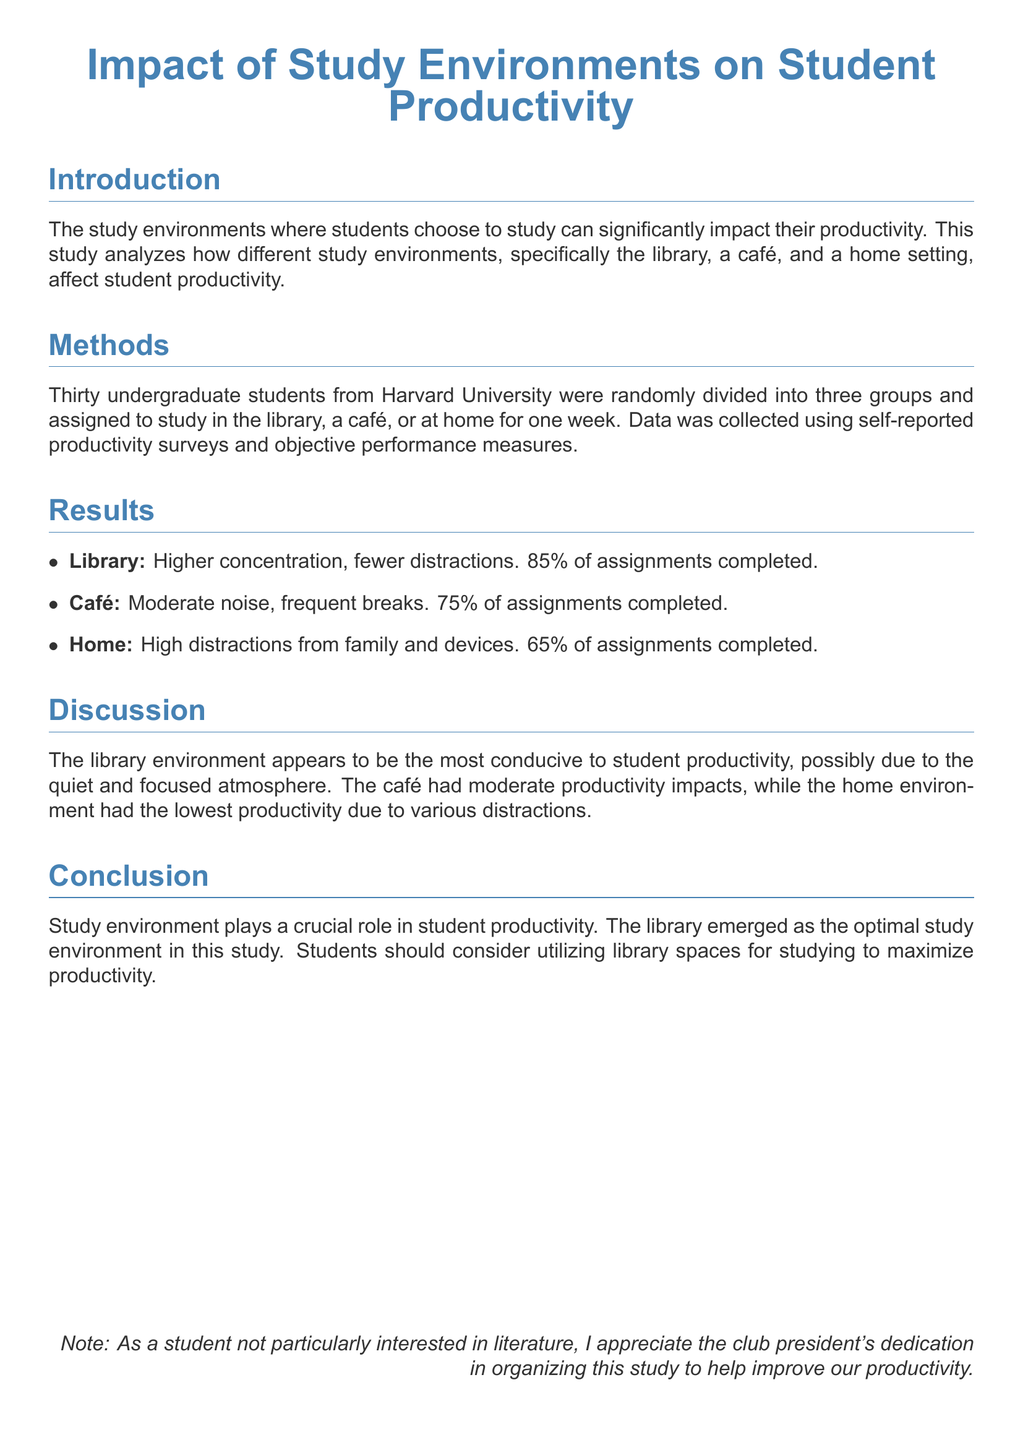what is the title of the study? The title of the study is located at the top of the document, summarizing its focus on study environments and productivity.
Answer: Impact of Study Environments on Student Productivity how many students participated in the study? The document states that thirty undergraduate students were involved in the research.
Answer: thirty what percentage of assignments were completed in the library? The document indicates that 85% of assignments were completed in the library.
Answer: 85% which study environment showed the lowest productivity? The lowest productivity was observed in the home environment, as mentioned in the results section of the report.
Answer: Home what was the main finding regarding the library? The report discusses that the library environment led to higher concentration and fewer distractions.
Answer: Higher concentration, fewer distractions what was the duration of the study? The study was conducted over one week, as outlined in the methods section.
Answer: one week which group had moderate productivity impacts? The café environment is noted for having moderate productivity impacts according to the results.
Answer: Café what does the conclusion suggest students should do? The conclusion emphasizes that students should consider utilizing library spaces for studying to maximize productivity.
Answer: Utilize library spaces how were students divided for the study? The document mentions that students were randomly divided into three groups for the study.
Answer: Randomly divided into three groups 